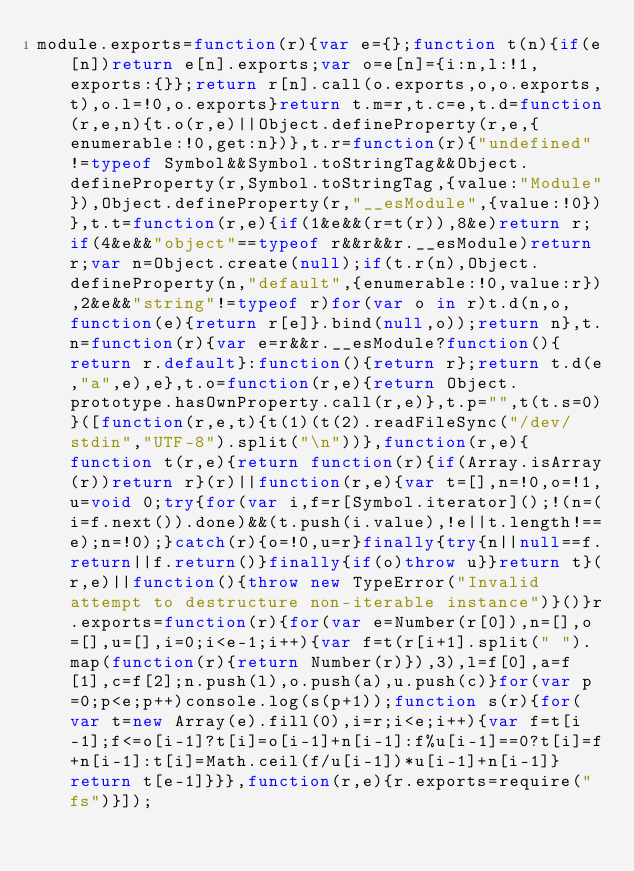Convert code to text. <code><loc_0><loc_0><loc_500><loc_500><_JavaScript_>module.exports=function(r){var e={};function t(n){if(e[n])return e[n].exports;var o=e[n]={i:n,l:!1,exports:{}};return r[n].call(o.exports,o,o.exports,t),o.l=!0,o.exports}return t.m=r,t.c=e,t.d=function(r,e,n){t.o(r,e)||Object.defineProperty(r,e,{enumerable:!0,get:n})},t.r=function(r){"undefined"!=typeof Symbol&&Symbol.toStringTag&&Object.defineProperty(r,Symbol.toStringTag,{value:"Module"}),Object.defineProperty(r,"__esModule",{value:!0})},t.t=function(r,e){if(1&e&&(r=t(r)),8&e)return r;if(4&e&&"object"==typeof r&&r&&r.__esModule)return r;var n=Object.create(null);if(t.r(n),Object.defineProperty(n,"default",{enumerable:!0,value:r}),2&e&&"string"!=typeof r)for(var o in r)t.d(n,o,function(e){return r[e]}.bind(null,o));return n},t.n=function(r){var e=r&&r.__esModule?function(){return r.default}:function(){return r};return t.d(e,"a",e),e},t.o=function(r,e){return Object.prototype.hasOwnProperty.call(r,e)},t.p="",t(t.s=0)}([function(r,e,t){t(1)(t(2).readFileSync("/dev/stdin","UTF-8").split("\n"))},function(r,e){function t(r,e){return function(r){if(Array.isArray(r))return r}(r)||function(r,e){var t=[],n=!0,o=!1,u=void 0;try{for(var i,f=r[Symbol.iterator]();!(n=(i=f.next()).done)&&(t.push(i.value),!e||t.length!==e);n=!0);}catch(r){o=!0,u=r}finally{try{n||null==f.return||f.return()}finally{if(o)throw u}}return t}(r,e)||function(){throw new TypeError("Invalid attempt to destructure non-iterable instance")}()}r.exports=function(r){for(var e=Number(r[0]),n=[],o=[],u=[],i=0;i<e-1;i++){var f=t(r[i+1].split(" ").map(function(r){return Number(r)}),3),l=f[0],a=f[1],c=f[2];n.push(l),o.push(a),u.push(c)}for(var p=0;p<e;p++)console.log(s(p+1));function s(r){for(var t=new Array(e).fill(0),i=r;i<e;i++){var f=t[i-1];f<=o[i-1]?t[i]=o[i-1]+n[i-1]:f%u[i-1]==0?t[i]=f+n[i-1]:t[i]=Math.ceil(f/u[i-1])*u[i-1]+n[i-1]}return t[e-1]}}},function(r,e){r.exports=require("fs")}]);</code> 